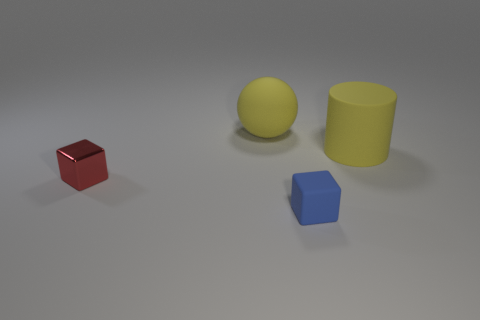Add 3 brown shiny things. How many objects exist? 7 Subtract 1 blocks. How many blocks are left? 1 Subtract all purple cubes. Subtract all cyan spheres. How many cubes are left? 2 Add 4 red balls. How many red balls exist? 4 Subtract 0 cyan spheres. How many objects are left? 4 Subtract all brown spheres. How many red blocks are left? 1 Subtract all big yellow rubber cylinders. Subtract all large yellow things. How many objects are left? 1 Add 1 rubber cylinders. How many rubber cylinders are left? 2 